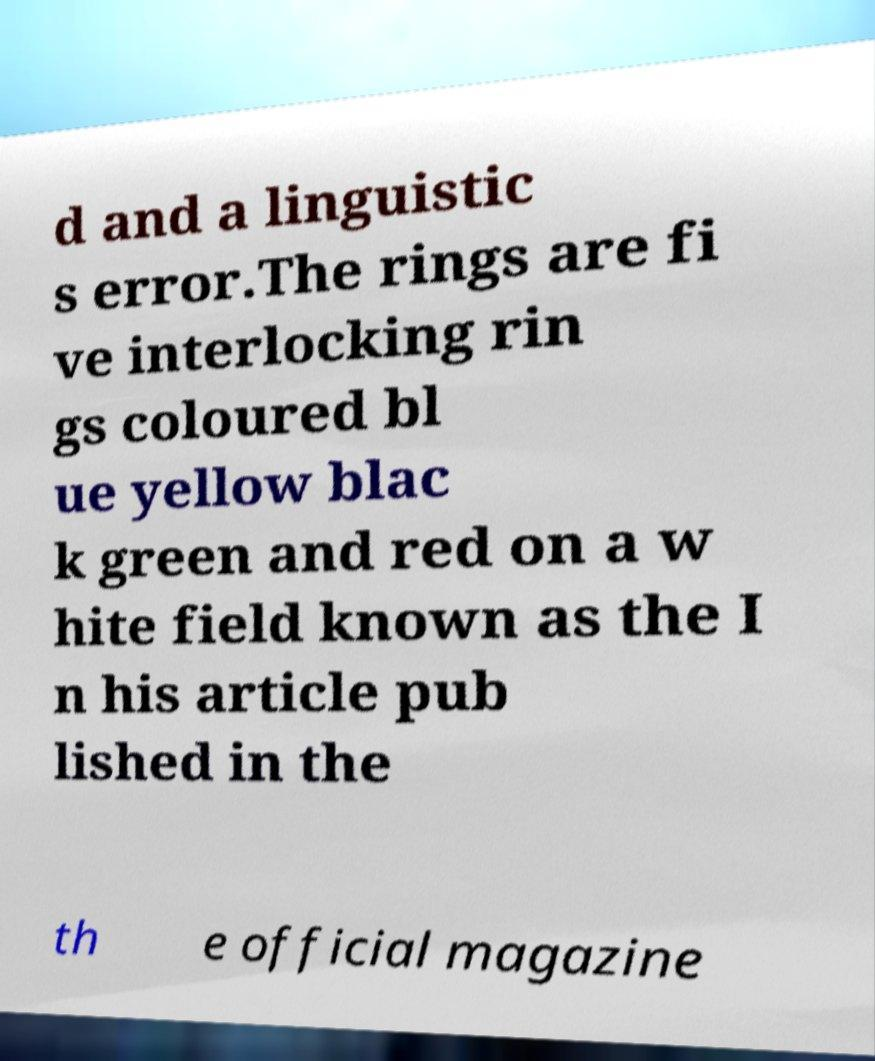I need the written content from this picture converted into text. Can you do that? d and a linguistic s error.The rings are fi ve interlocking rin gs coloured bl ue yellow blac k green and red on a w hite field known as the I n his article pub lished in the th e official magazine 